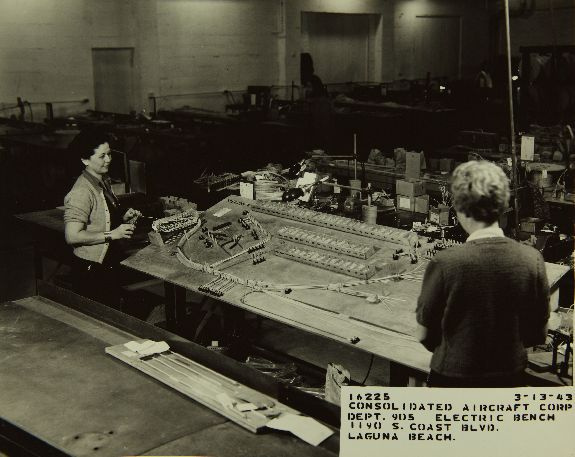Please extract the text content from this image. CONSOL DATED 1 DEPT 9DS 3 4 3 1 3 AIRCRAFT CORP BENCH ELETRIC LIVE S BLVD coast BEACH LAGUNA 225 